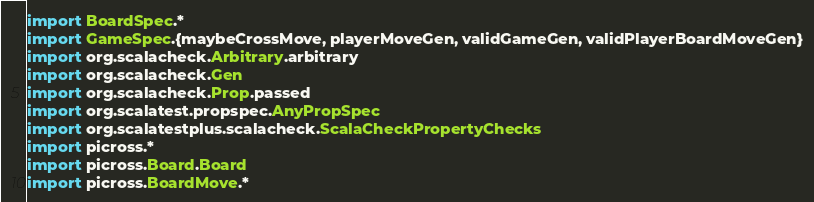<code> <loc_0><loc_0><loc_500><loc_500><_Scala_>import BoardSpec.*
import GameSpec.{maybeCrossMove, playerMoveGen, validGameGen, validPlayerBoardMoveGen}
import org.scalacheck.Arbitrary.arbitrary
import org.scalacheck.Gen
import org.scalacheck.Prop.passed
import org.scalatest.propspec.AnyPropSpec
import org.scalatestplus.scalacheck.ScalaCheckPropertyChecks
import picross.*
import picross.Board.Board
import picross.BoardMove.*</code> 